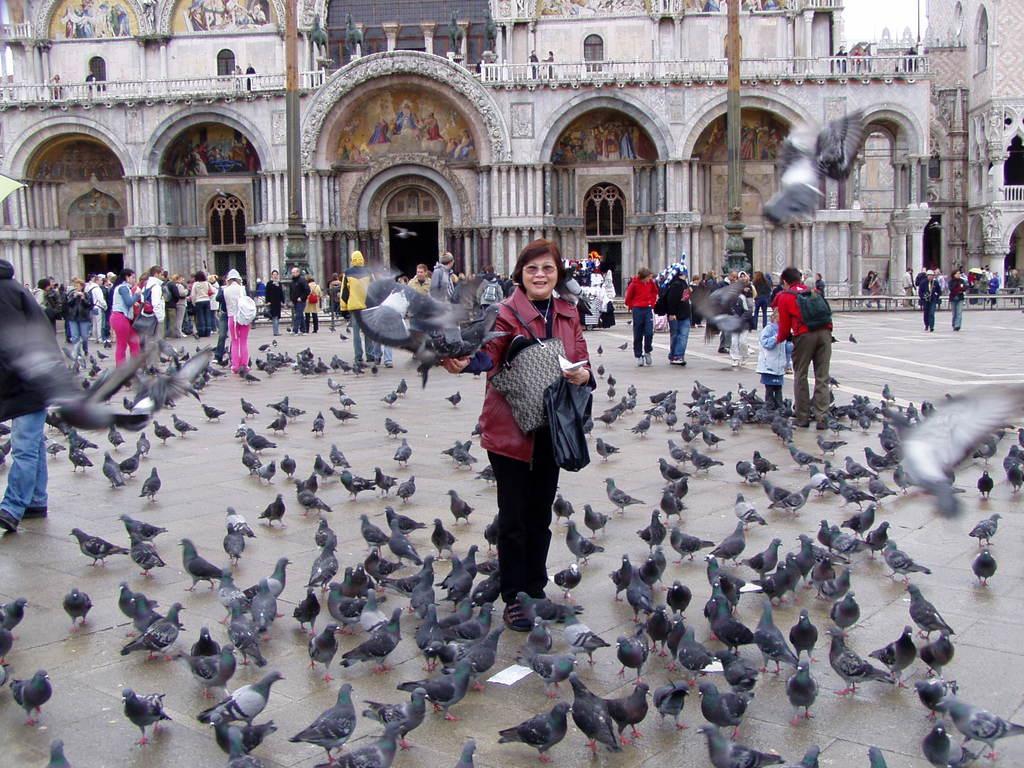Could you give a brief overview of what you see in this image? In this image we can see birds. Also there are people. Some are holding bags. In the back there are buildings with arches, pillars and doors. On the walls of the building there are paintings. 